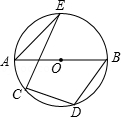In the provided diagram, where AB is the diameter of circle O and points C, D, E lie on circle O, if angle AEC has a measurement of 20.0 degrees, what is the value of angle BDC? In the given circle diagram, with AB as the diameter and points C, D, and E resting on the circle's circumference, we start by identifying angle AEC as 20 degrees. Since AB acts as the circle's diameter, any triangle touching A and B creates a right triangle at the circle’s circumference, so angle AEB inherently meansures 90 degrees. Subtracting angle AEC's 20 degrees from angle AEB gives us 70 degrees for angle BEC. Circles have the property that a line through the center, such as BD, splits the opposite arc evenly, implying that angle BDC and angle BEC together must complete a half-circle, or 180 degrees. Thus, angle BDC is logically 110 degrees. Our precise reasoning confirms that answer is B: 110 degrees. 